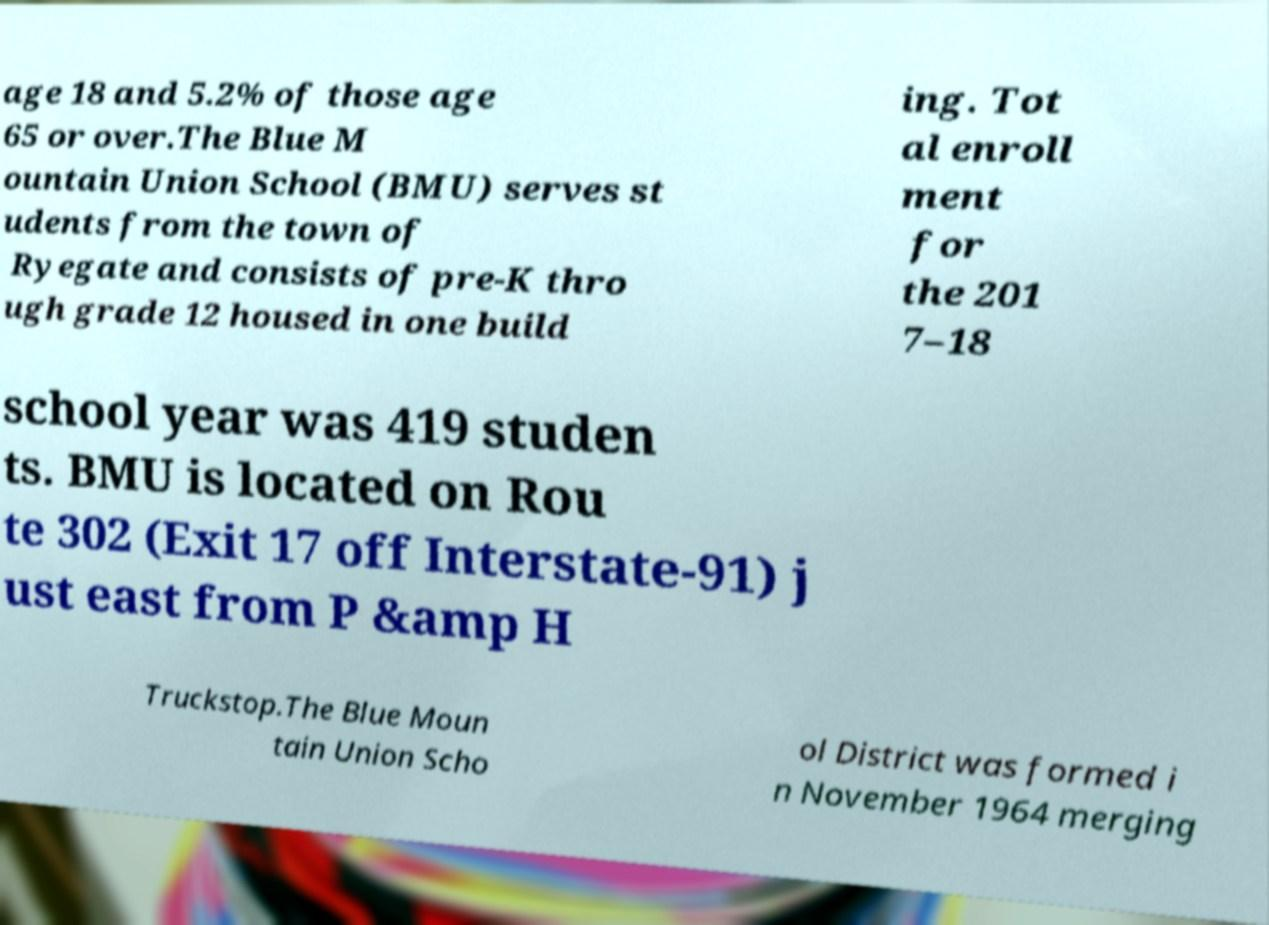Can you read and provide the text displayed in the image?This photo seems to have some interesting text. Can you extract and type it out for me? age 18 and 5.2% of those age 65 or over.The Blue M ountain Union School (BMU) serves st udents from the town of Ryegate and consists of pre-K thro ugh grade 12 housed in one build ing. Tot al enroll ment for the 201 7–18 school year was 419 studen ts. BMU is located on Rou te 302 (Exit 17 off Interstate-91) j ust east from P &amp H Truckstop.The Blue Moun tain Union Scho ol District was formed i n November 1964 merging 